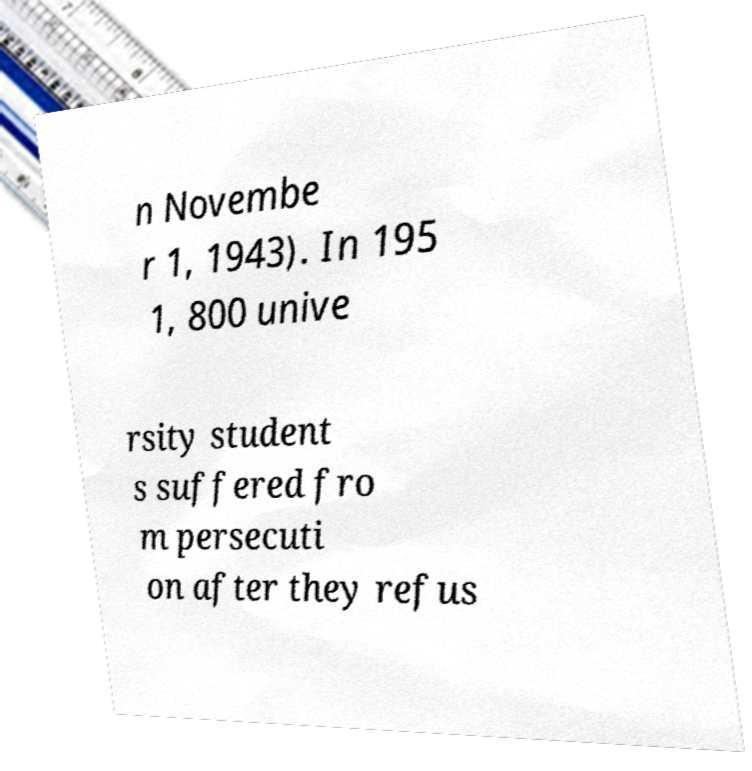Can you accurately transcribe the text from the provided image for me? n Novembe r 1, 1943). In 195 1, 800 unive rsity student s suffered fro m persecuti on after they refus 